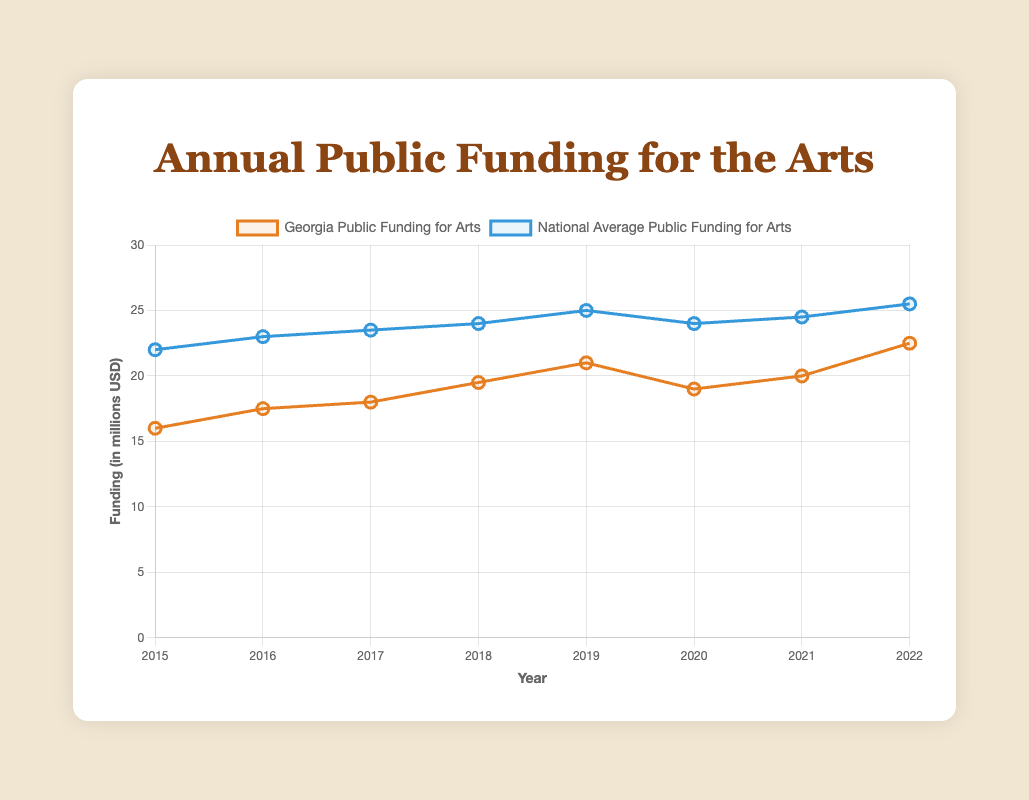What's the trend of public funding for the arts in Georgia from 2015 to 2022? The funding amount in Georgia generally increases over the years. Starting from 16.0 million in 2015 and rising to 22.5 million in 2022, with a slight dip in 2020 (19.0 million) and some fluctuations in between.
Answer: Increasing with some fluctuations In which year did Georgia have the highest public funding for the arts? The highest funding in Georgia for the arts was in 2022, at 22.5 million USD.
Answer: 2022 How does the public funding for the arts in Georgia in 2020 compare to the national average in the same year? In 2020, Georgia's public funding for the arts was 19.0 million USD, while the national average was 24.0 million USD. Georgia's funding was 5 million USD lower than the national average.
Answer: 5 million USD lower What is the total public funding for the arts in Georgia from 2015 to 2022? Summing the values from 2015 to 2022 (16.0 + 17.5 + 18.0 + 19.5 + 21.0 + 19.0 + 20.0 + 22.5), the total public funding for the arts in Georgia is 153.5 million USD.
Answer: 153.5 million USD In which year did the public funding for the arts in Georgia have the biggest increase from the previous year? The biggest increase occurred between 2021 and 2022, where the funding increased from 20.0 to 22.5 million USD, an increase of 2.5 million USD.
Answer: 2021 to 2022 Is there any year when the public funding for the arts in Georgia decreased? If yes, when? Yes, the funding decreased from 21.0 million USD in 2019 to 19.0 million USD in 2020.
Answer: 2019 to 2020 How does the trend in public funding for the arts in Georgia compare with the national average from 2015 to 2022? Both trends show an overall increase over the years. However, the national average is generally higher than Georgia's funding. Also, the national trend is smoother compared to Georgia's which has more fluctuations.
Answer: Both increase, national average higher By how much did the national average for public funding for the arts change from 2016 to 2022? The national average funding went from 23.0 million USD in 2016 to 25.5 million USD in 2022, an increase of 2.5 million USD.
Answer: 2.5 million USD Which year has the smallest gap between Georgia's funding and the national average? The smallest gap is in 2015, where Georgia's funding is 16.0 million USD and the national average is 22.0 million USD, a gap of 6.0 million USD.
Answer: 2015 